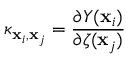<formula> <loc_0><loc_0><loc_500><loc_500>\kappa _ { x _ { i } , x _ { j } } = \frac { \partial Y ( x _ { i } ) } { \partial \zeta ( x _ { j } ) }</formula> 